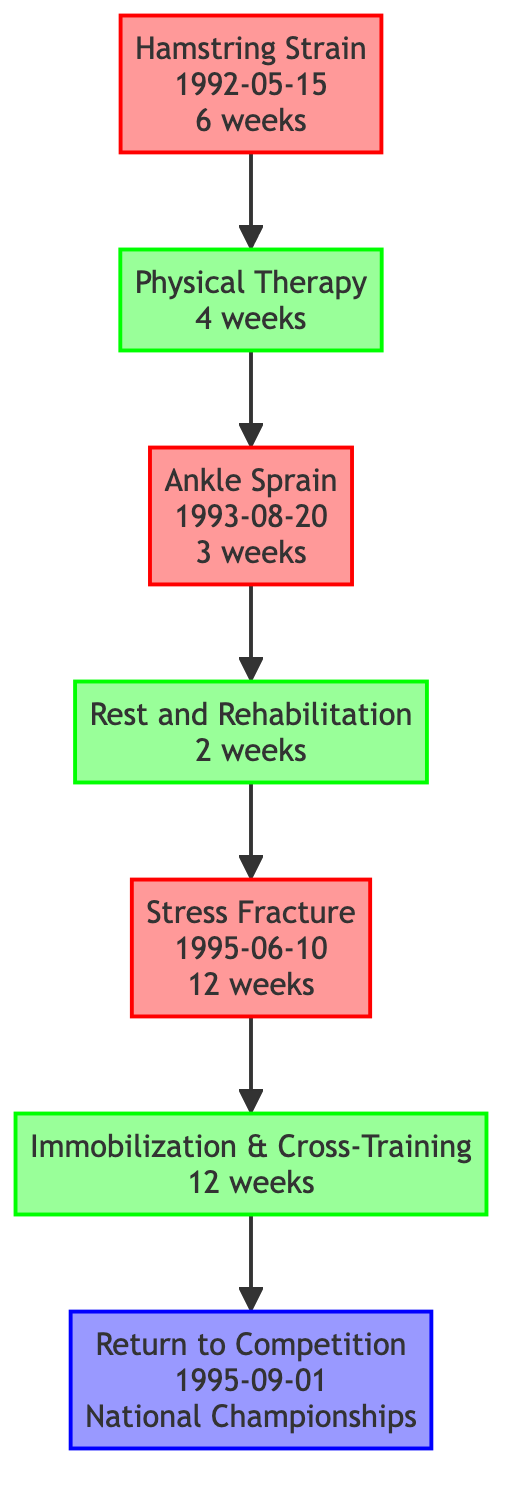What is the first injury listed in the diagram? The diagram lists "Hamstring Strain" as the first injury, indicated by the label of Injury_1.
Answer: Hamstring Strain How long did the Hamstring Strain last? The duration of the Hamstring Strain is specified in its details as "6 weeks."
Answer: 6 weeks What type of recovery is associated with the Stress Fracture? The recovery associated with the Stress Fracture is "Immobilization & Cross-Training," as noted in the Recovery_3 node linked to Injury_3.
Answer: Immobilization & Cross-Training How many total injuries are depicted in the diagram? The diagram lists three injuries: Hamstring Strain, Ankle Sprain, and Stress Fracture, indicating a total of three injuries in the nodes.
Answer: 3 What recovery protocol is used after the Ankle Sprain? The protocol used after the Ankle Sprain is "RICE method and gradual return to activity," detailed in the Recovery_2 node.
Answer: RICE method and gradual return to activity What is the timeline for returning to competition after the last injury? The return to competition occurs on "1995-09-01" after the last recovery, which is indicated by the Return_1 node that follows the Recovery_3 node.
Answer: 1995-09-01 Which injury is followed by physical therapy? The "Hamstring Strain" injury is followed by the "Physical Therapy" recovery, as shown by the directed edge from Injury_1 to Recovery_1.
Answer: Hamstring Strain How many edges are present in the diagram? The diagram has six edges connecting injuries to recoveries and recoveries to the return event, illustrating the flow of recovery.
Answer: 6 What was the performance outcome upon return to competition? The outcome upon return to competition was winning a "Gold medal in 100 meters," as indicated in the details of the Return_1 node.
Answer: Gold medal in 100 meters 